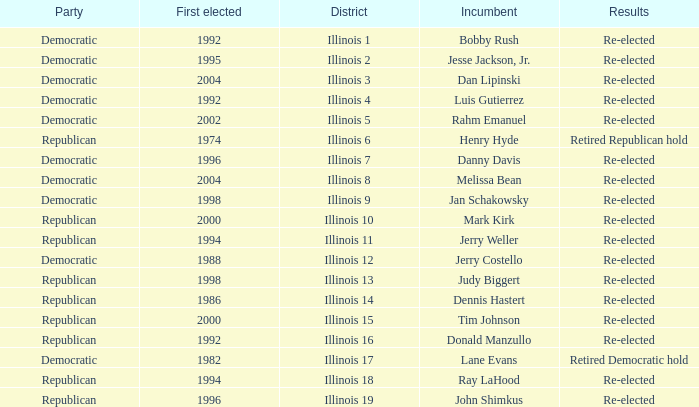What is the First Elected date of the Republican with Results of retired republican hold? 1974.0. 